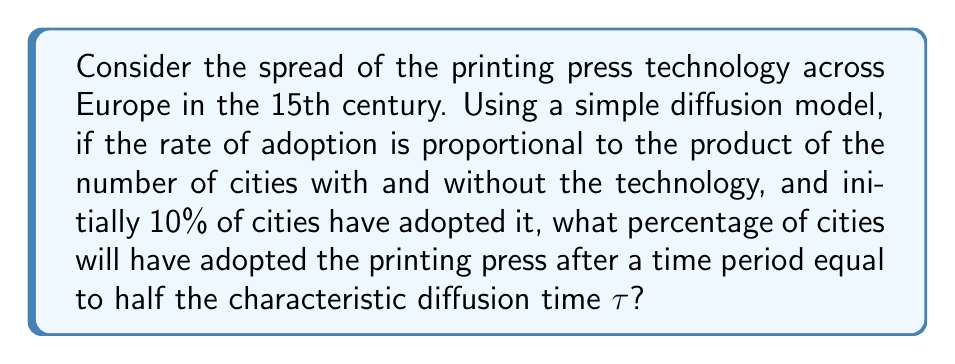Can you answer this question? Let's approach this step-by-step using the logistic growth model, which is a common diffusion equation:

1) The logistic equation is given by:
   $$\frac{dN}{dt} = rN(1-\frac{N}{K})$$
   where $N$ is the number of adopters, $K$ is the total population, and $r$ is the growth rate.

2) The solution to this equation is:
   $$N(t) = \frac{K}{1 + (\frac{K}{N_0} - 1)e^{-rt}}$$
   where $N_0$ is the initial number of adopters.

3) We're given that initially 10% of cities have adopted, so $N_0 = 0.1K$.

4) The characteristic time $\tau$ is defined as $\tau = \frac{1}{r}$.

5) We want to find $N(t)$ at $t = \frac{\tau}{2} = \frac{1}{2r}$.

6) Substituting these into our solution:
   $$N(\frac{\tau}{2}) = \frac{K}{1 + (\frac{K}{0.1K} - 1)e^{-r(\frac{1}{2r})}}$$

7) Simplifying:
   $$N(\frac{\tau}{2}) = \frac{K}{1 + 9e^{-\frac{1}{2}}}$$

8) Calculating:
   $$N(\frac{\tau}{2}) \approx 0.2689K$$

9) Converting to a percentage:
   $0.2689 * 100\% \approx 26.89\%$
Answer: 26.89% 